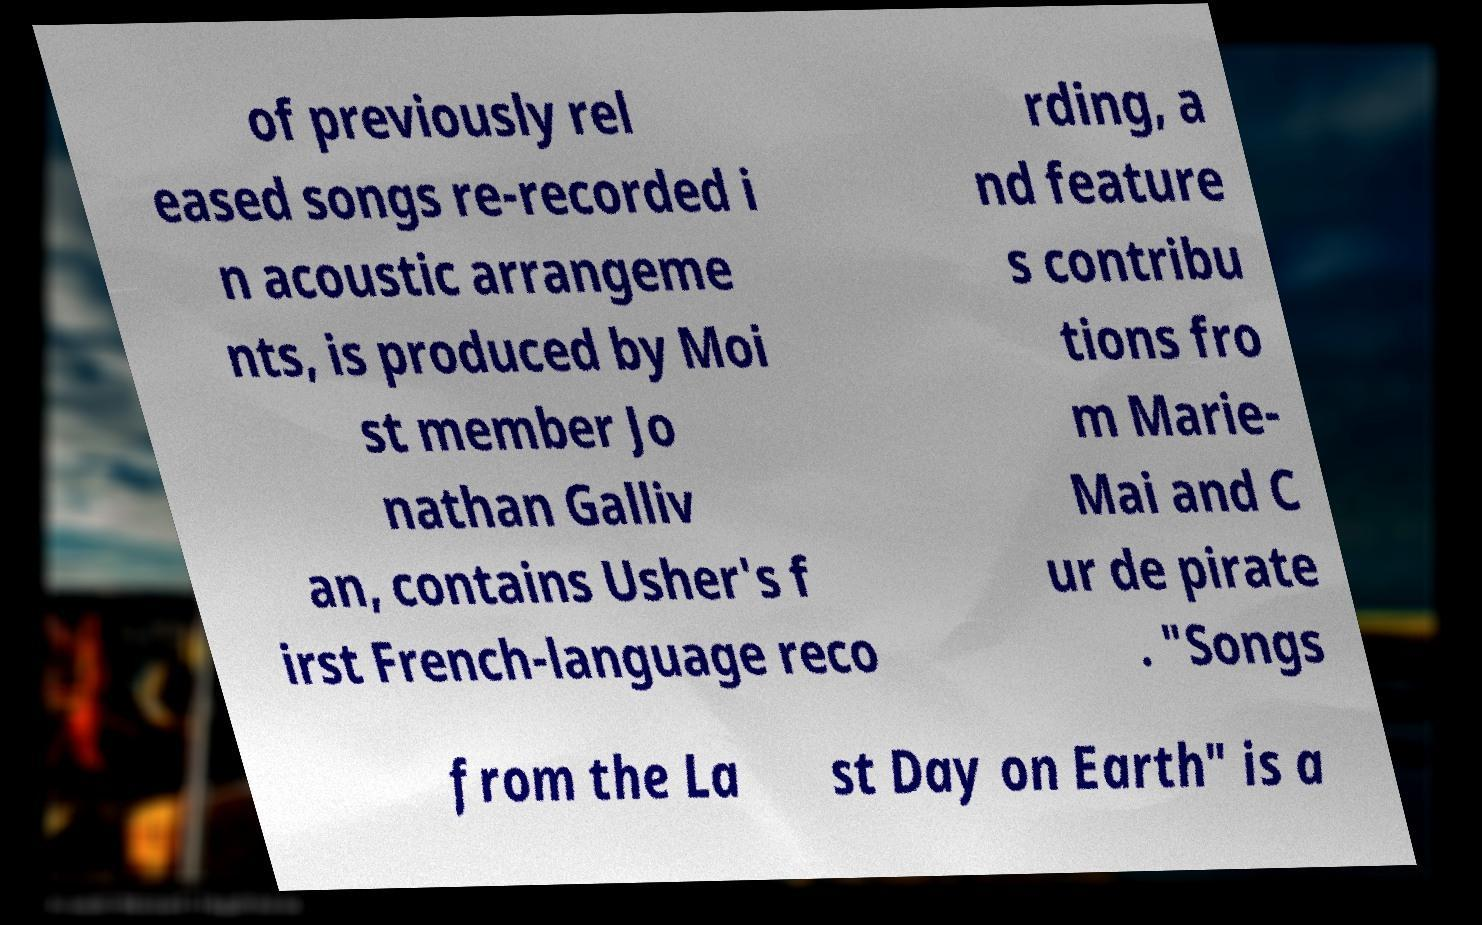Please read and relay the text visible in this image. What does it say? of previously rel eased songs re-recorded i n acoustic arrangeme nts, is produced by Moi st member Jo nathan Galliv an, contains Usher's f irst French-language reco rding, a nd feature s contribu tions fro m Marie- Mai and C ur de pirate . "Songs from the La st Day on Earth" is a 